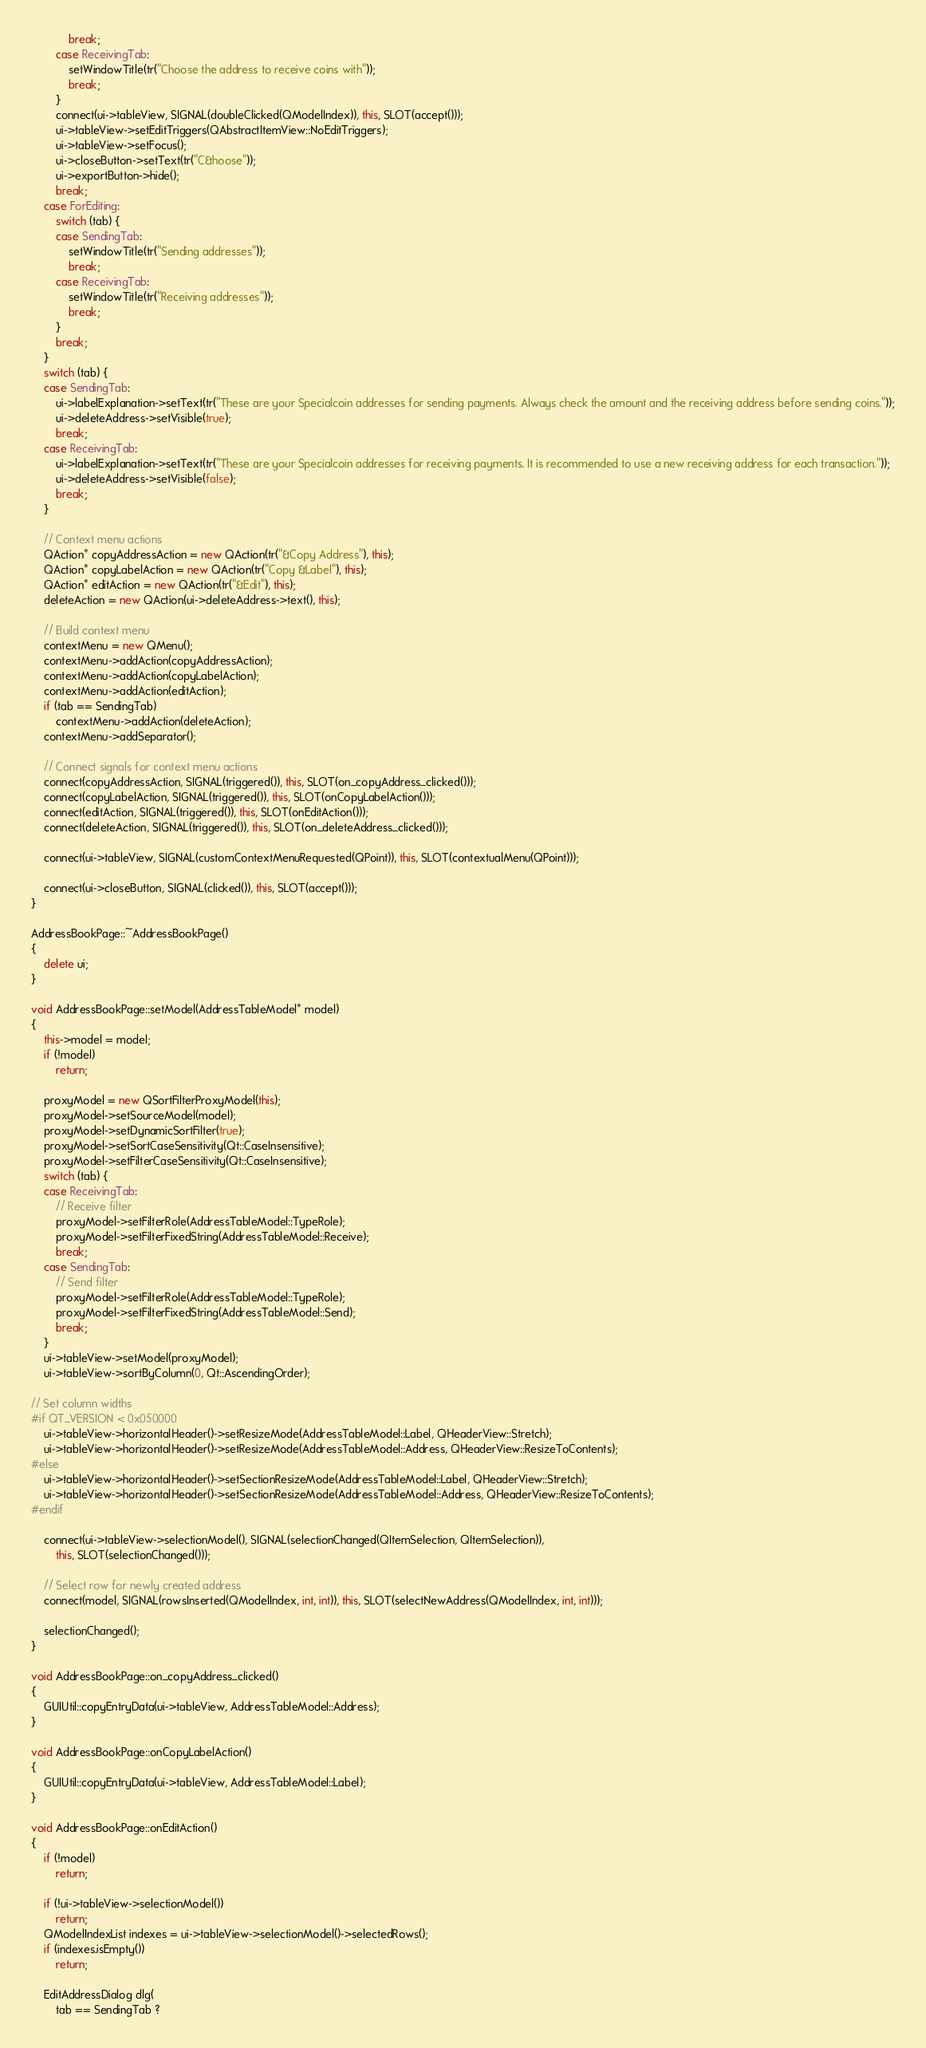Convert code to text. <code><loc_0><loc_0><loc_500><loc_500><_C++_>            break;
        case ReceivingTab:
            setWindowTitle(tr("Choose the address to receive coins with"));
            break;
        }
        connect(ui->tableView, SIGNAL(doubleClicked(QModelIndex)), this, SLOT(accept()));
        ui->tableView->setEditTriggers(QAbstractItemView::NoEditTriggers);
        ui->tableView->setFocus();
        ui->closeButton->setText(tr("C&hoose"));
        ui->exportButton->hide();
        break;
    case ForEditing:
        switch (tab) {
        case SendingTab:
            setWindowTitle(tr("Sending addresses"));
            break;
        case ReceivingTab:
            setWindowTitle(tr("Receiving addresses"));
            break;
        }
        break;
    }
    switch (tab) {
    case SendingTab:
        ui->labelExplanation->setText(tr("These are your Specialcoin addresses for sending payments. Always check the amount and the receiving address before sending coins."));
        ui->deleteAddress->setVisible(true);
        break;
    case ReceivingTab:
        ui->labelExplanation->setText(tr("These are your Specialcoin addresses for receiving payments. It is recommended to use a new receiving address for each transaction."));
        ui->deleteAddress->setVisible(false);
        break;
    }

    // Context menu actions
    QAction* copyAddressAction = new QAction(tr("&Copy Address"), this);
    QAction* copyLabelAction = new QAction(tr("Copy &Label"), this);
    QAction* editAction = new QAction(tr("&Edit"), this);
    deleteAction = new QAction(ui->deleteAddress->text(), this);

    // Build context menu
    contextMenu = new QMenu();
    contextMenu->addAction(copyAddressAction);
    contextMenu->addAction(copyLabelAction);
    contextMenu->addAction(editAction);
    if (tab == SendingTab)
        contextMenu->addAction(deleteAction);
    contextMenu->addSeparator();

    // Connect signals for context menu actions
    connect(copyAddressAction, SIGNAL(triggered()), this, SLOT(on_copyAddress_clicked()));
    connect(copyLabelAction, SIGNAL(triggered()), this, SLOT(onCopyLabelAction()));
    connect(editAction, SIGNAL(triggered()), this, SLOT(onEditAction()));
    connect(deleteAction, SIGNAL(triggered()), this, SLOT(on_deleteAddress_clicked()));

    connect(ui->tableView, SIGNAL(customContextMenuRequested(QPoint)), this, SLOT(contextualMenu(QPoint)));

    connect(ui->closeButton, SIGNAL(clicked()), this, SLOT(accept()));
}

AddressBookPage::~AddressBookPage()
{
    delete ui;
}

void AddressBookPage::setModel(AddressTableModel* model)
{
    this->model = model;
    if (!model)
        return;

    proxyModel = new QSortFilterProxyModel(this);
    proxyModel->setSourceModel(model);
    proxyModel->setDynamicSortFilter(true);
    proxyModel->setSortCaseSensitivity(Qt::CaseInsensitive);
    proxyModel->setFilterCaseSensitivity(Qt::CaseInsensitive);
    switch (tab) {
    case ReceivingTab:
        // Receive filter
        proxyModel->setFilterRole(AddressTableModel::TypeRole);
        proxyModel->setFilterFixedString(AddressTableModel::Receive);
        break;
    case SendingTab:
        // Send filter
        proxyModel->setFilterRole(AddressTableModel::TypeRole);
        proxyModel->setFilterFixedString(AddressTableModel::Send);
        break;
    }
    ui->tableView->setModel(proxyModel);
    ui->tableView->sortByColumn(0, Qt::AscendingOrder);

// Set column widths
#if QT_VERSION < 0x050000
    ui->tableView->horizontalHeader()->setResizeMode(AddressTableModel::Label, QHeaderView::Stretch);
    ui->tableView->horizontalHeader()->setResizeMode(AddressTableModel::Address, QHeaderView::ResizeToContents);
#else
    ui->tableView->horizontalHeader()->setSectionResizeMode(AddressTableModel::Label, QHeaderView::Stretch);
    ui->tableView->horizontalHeader()->setSectionResizeMode(AddressTableModel::Address, QHeaderView::ResizeToContents);
#endif

    connect(ui->tableView->selectionModel(), SIGNAL(selectionChanged(QItemSelection, QItemSelection)),
        this, SLOT(selectionChanged()));

    // Select row for newly created address
    connect(model, SIGNAL(rowsInserted(QModelIndex, int, int)), this, SLOT(selectNewAddress(QModelIndex, int, int)));

    selectionChanged();
}

void AddressBookPage::on_copyAddress_clicked()
{
    GUIUtil::copyEntryData(ui->tableView, AddressTableModel::Address);
}

void AddressBookPage::onCopyLabelAction()
{
    GUIUtil::copyEntryData(ui->tableView, AddressTableModel::Label);
}

void AddressBookPage::onEditAction()
{
    if (!model)
        return;

    if (!ui->tableView->selectionModel())
        return;
    QModelIndexList indexes = ui->tableView->selectionModel()->selectedRows();
    if (indexes.isEmpty())
        return;

    EditAddressDialog dlg(
        tab == SendingTab ?</code> 